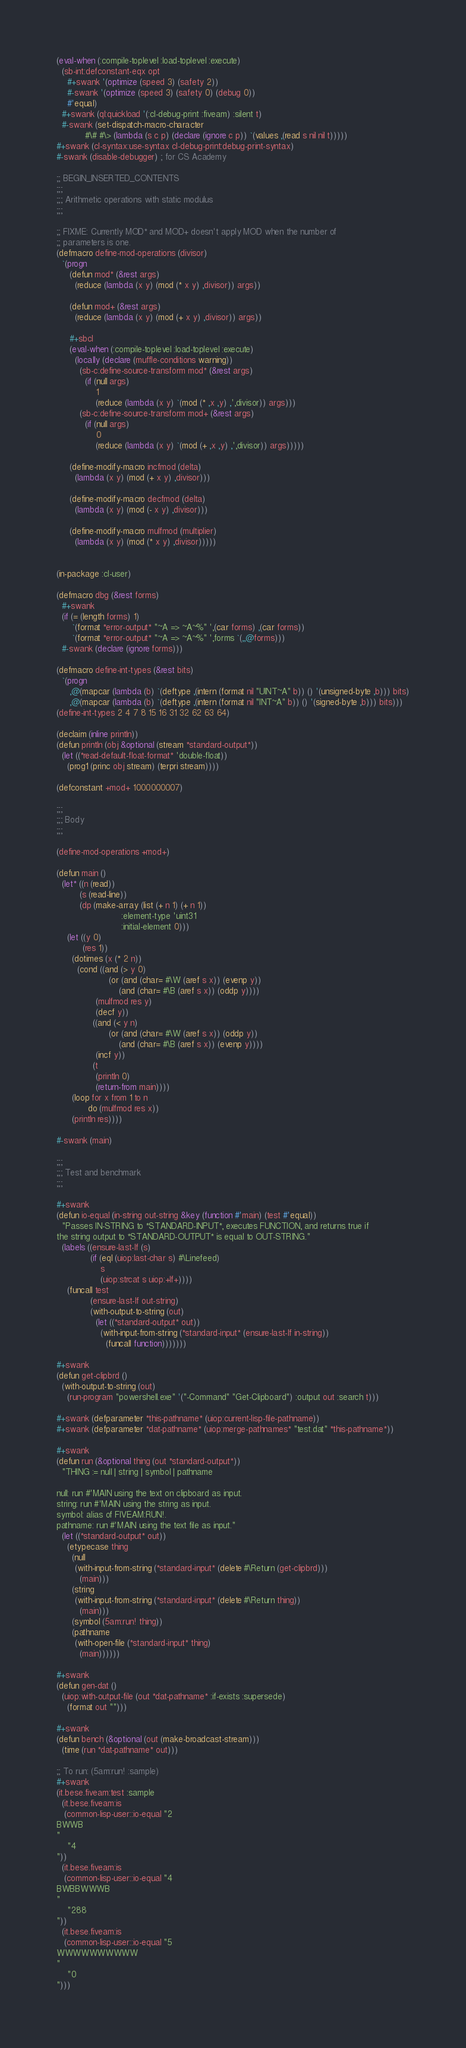Convert code to text. <code><loc_0><loc_0><loc_500><loc_500><_Lisp_>(eval-when (:compile-toplevel :load-toplevel :execute)
  (sb-int:defconstant-eqx opt
    #+swank '(optimize (speed 3) (safety 2))
    #-swank '(optimize (speed 3) (safety 0) (debug 0))
    #'equal)
  #+swank (ql:quickload '(:cl-debug-print :fiveam) :silent t)
  #-swank (set-dispatch-macro-character
           #\# #\> (lambda (s c p) (declare (ignore c p)) `(values ,(read s nil nil t)))))
#+swank (cl-syntax:use-syntax cl-debug-print:debug-print-syntax)
#-swank (disable-debugger) ; for CS Academy

;; BEGIN_INSERTED_CONTENTS
;;;
;;; Arithmetic operations with static modulus
;;;

;; FIXME: Currently MOD* and MOD+ doesn't apply MOD when the number of
;; parameters is one.
(defmacro define-mod-operations (divisor)
  `(progn
     (defun mod* (&rest args)
       (reduce (lambda (x y) (mod (* x y) ,divisor)) args))

     (defun mod+ (&rest args)
       (reduce (lambda (x y) (mod (+ x y) ,divisor)) args))

     #+sbcl
     (eval-when (:compile-toplevel :load-toplevel :execute)
       (locally (declare (muffle-conditions warning))
         (sb-c:define-source-transform mod* (&rest args)
           (if (null args)
               1
               (reduce (lambda (x y) `(mod (* ,x ,y) ,',divisor)) args)))
         (sb-c:define-source-transform mod+ (&rest args)
           (if (null args)
               0
               (reduce (lambda (x y) `(mod (+ ,x ,y) ,',divisor)) args)))))

     (define-modify-macro incfmod (delta)
       (lambda (x y) (mod (+ x y) ,divisor)))

     (define-modify-macro decfmod (delta)
       (lambda (x y) (mod (- x y) ,divisor)))

     (define-modify-macro mulfmod (multiplier)
       (lambda (x y) (mod (* x y) ,divisor)))))


(in-package :cl-user)

(defmacro dbg (&rest forms)
  #+swank
  (if (= (length forms) 1)
      `(format *error-output* "~A => ~A~%" ',(car forms) ,(car forms))
      `(format *error-output* "~A => ~A~%" ',forms `(,,@forms)))
  #-swank (declare (ignore forms)))

(defmacro define-int-types (&rest bits)
  `(progn
     ,@(mapcar (lambda (b) `(deftype ,(intern (format nil "UINT~A" b)) () '(unsigned-byte ,b))) bits)
     ,@(mapcar (lambda (b) `(deftype ,(intern (format nil "INT~A" b)) () '(signed-byte ,b))) bits)))
(define-int-types 2 4 7 8 15 16 31 32 62 63 64)

(declaim (inline println))
(defun println (obj &optional (stream *standard-output*))
  (let ((*read-default-float-format* 'double-float))
    (prog1 (princ obj stream) (terpri stream))))

(defconstant +mod+ 1000000007)

;;;
;;; Body
;;;

(define-mod-operations +mod+)

(defun main ()
  (let* ((n (read))
         (s (read-line))
         (dp (make-array (list (+ n 1) (+ n 1))
                         :element-type 'uint31
                         :initial-element 0)))
    (let ((y 0)
          (res 1))
      (dotimes (x (* 2 n))
        (cond ((and (> y 0)
                    (or (and (char= #\W (aref s x)) (evenp y))
                        (and (char= #\B (aref s x)) (oddp y))))
               (mulfmod res y)
               (decf y))
              ((and (< y n)
                    (or (and (char= #\W (aref s x)) (oddp y))
                        (and (char= #\B (aref s x)) (evenp y))))
               (incf y))
              (t
               (println 0)
               (return-from main))))
      (loop for x from 1 to n
            do (mulfmod res x))
      (println res))))

#-swank (main)

;;;
;;; Test and benchmark
;;;

#+swank
(defun io-equal (in-string out-string &key (function #'main) (test #'equal))
  "Passes IN-STRING to *STANDARD-INPUT*, executes FUNCTION, and returns true if
the string output to *STANDARD-OUTPUT* is equal to OUT-STRING."
  (labels ((ensure-last-lf (s)
             (if (eql (uiop:last-char s) #\Linefeed)
                 s
                 (uiop:strcat s uiop:+lf+))))
    (funcall test
             (ensure-last-lf out-string)
             (with-output-to-string (out)
               (let ((*standard-output* out))
                 (with-input-from-string (*standard-input* (ensure-last-lf in-string))
                   (funcall function)))))))

#+swank
(defun get-clipbrd ()
  (with-output-to-string (out)
    (run-program "powershell.exe" '("-Command" "Get-Clipboard") :output out :search t)))

#+swank (defparameter *this-pathname* (uiop:current-lisp-file-pathname))
#+swank (defparameter *dat-pathname* (uiop:merge-pathnames* "test.dat" *this-pathname*))

#+swank
(defun run (&optional thing (out *standard-output*))
  "THING := null | string | symbol | pathname

null: run #'MAIN using the text on clipboard as input.
string: run #'MAIN using the string as input.
symbol: alias of FIVEAM:RUN!.
pathname: run #'MAIN using the text file as input."
  (let ((*standard-output* out))
    (etypecase thing
      (null
       (with-input-from-string (*standard-input* (delete #\Return (get-clipbrd)))
         (main)))
      (string
       (with-input-from-string (*standard-input* (delete #\Return thing))
         (main)))
      (symbol (5am:run! thing))
      (pathname
       (with-open-file (*standard-input* thing)
         (main))))))

#+swank
(defun gen-dat ()
  (uiop:with-output-file (out *dat-pathname* :if-exists :supersede)
    (format out "")))

#+swank
(defun bench (&optional (out (make-broadcast-stream)))
  (time (run *dat-pathname* out)))

;; To run: (5am:run! :sample)
#+swank
(it.bese.fiveam:test :sample
  (it.bese.fiveam:is
   (common-lisp-user::io-equal "2
BWWB
"
    "4
"))
  (it.bese.fiveam:is
   (common-lisp-user::io-equal "4
BWBBWWWB
"
    "288
"))
  (it.bese.fiveam:is
   (common-lisp-user::io-equal "5
WWWWWWWWWW
"
    "0
")))
</code> 